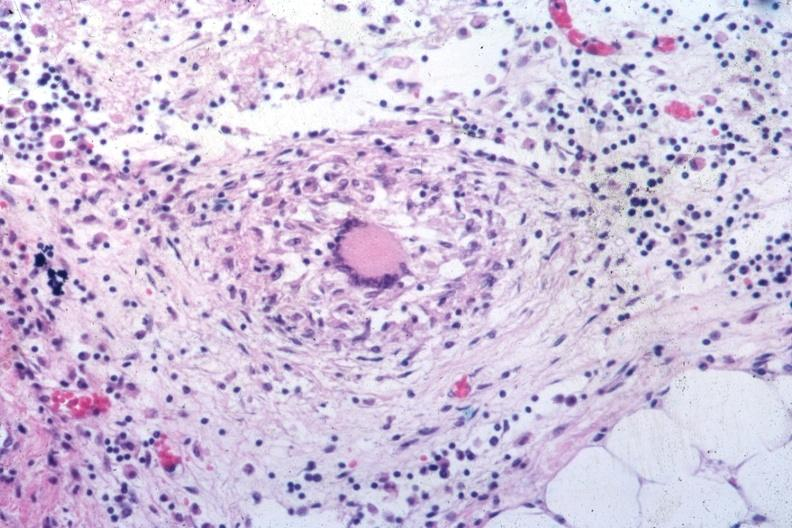what is present?
Answer the question using a single word or phrase. Abdomen 